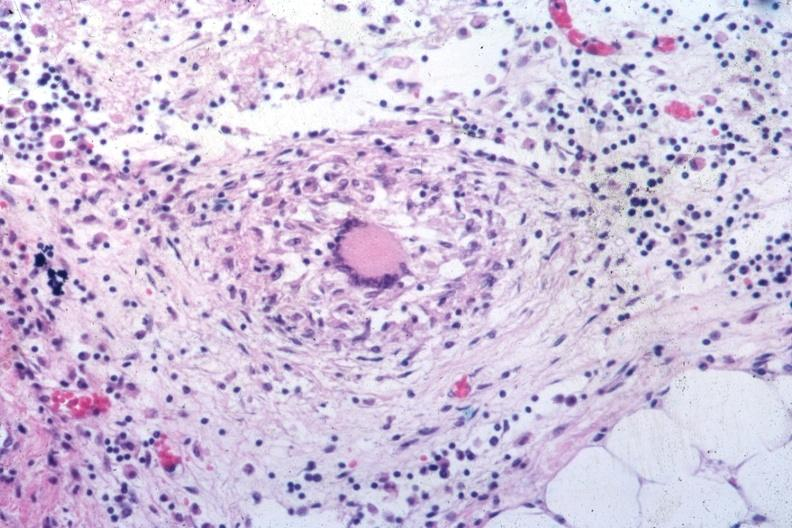what is present?
Answer the question using a single word or phrase. Abdomen 